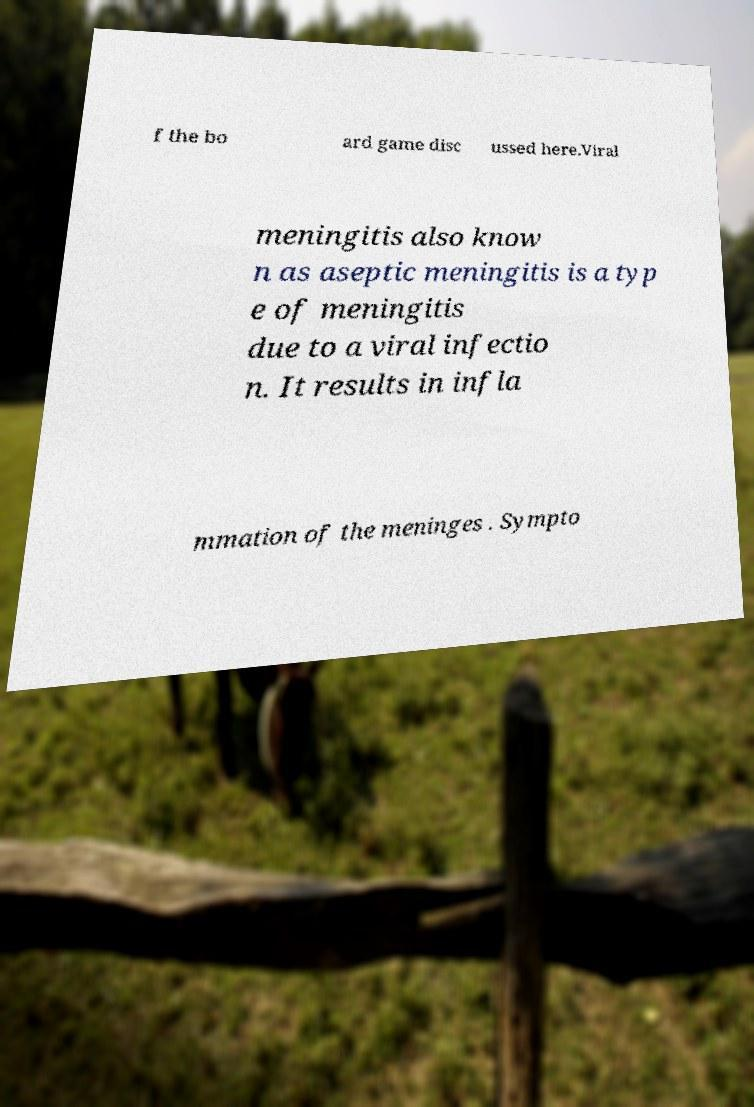Could you extract and type out the text from this image? f the bo ard game disc ussed here.Viral meningitis also know n as aseptic meningitis is a typ e of meningitis due to a viral infectio n. It results in infla mmation of the meninges . Sympto 